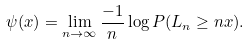Convert formula to latex. <formula><loc_0><loc_0><loc_500><loc_500>\psi ( x ) = \lim _ { n \to \infty } \frac { - 1 } { n } \log P ( L _ { n } \geq n x ) .</formula> 